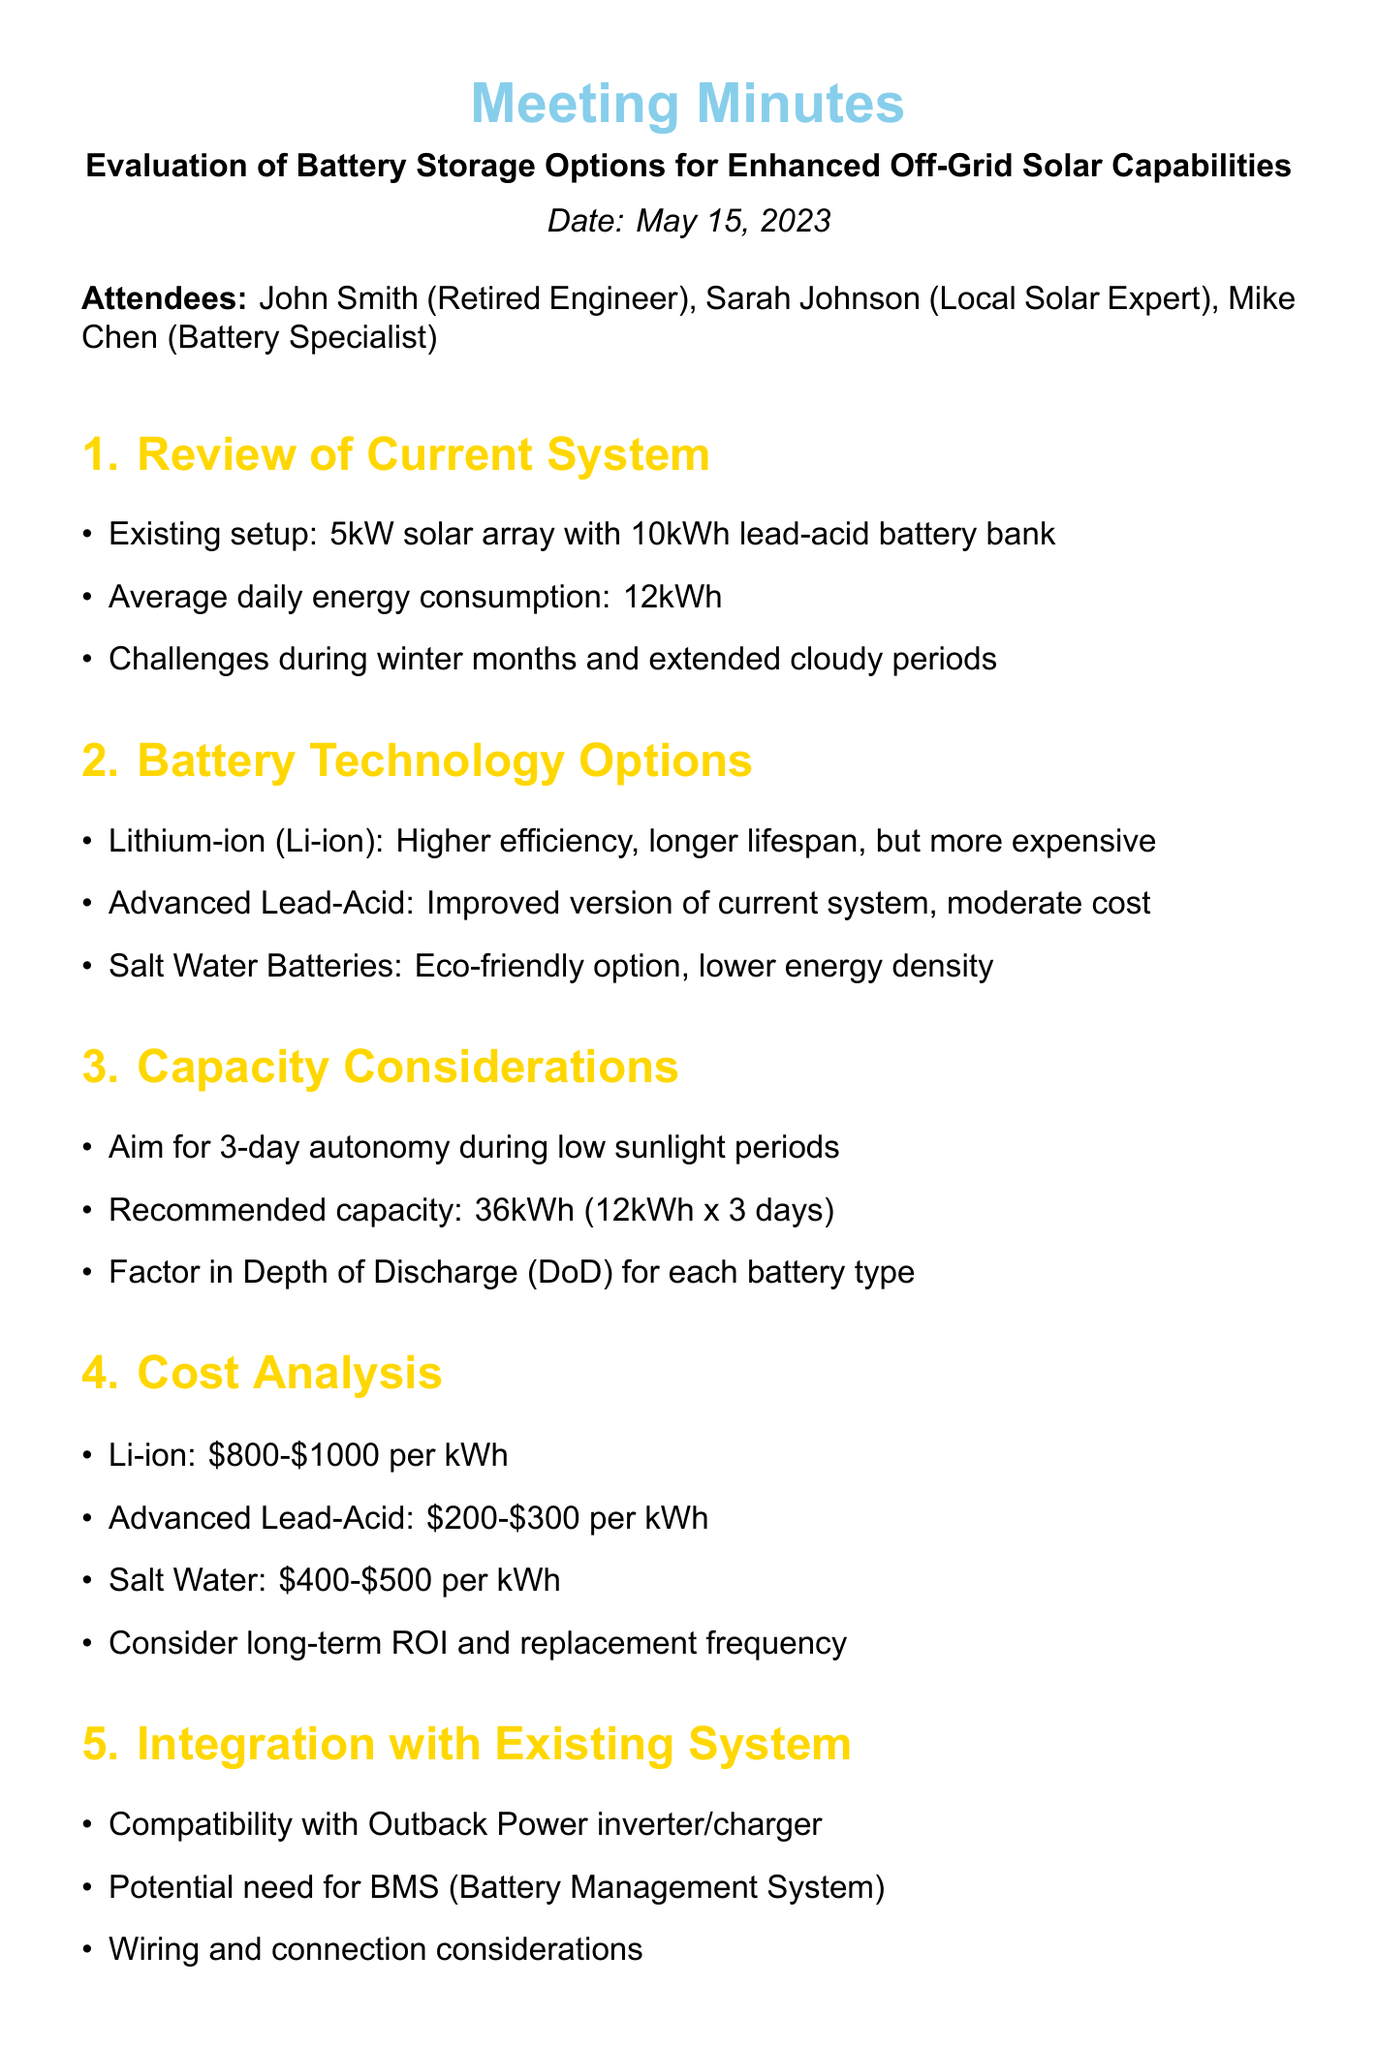What is the date of the meeting? The date of the meeting is specified in the document.
Answer: May 15, 2023 Who is the battery specialist in the meeting? The attendees list includes the roles and names of participants.
Answer: Mike Chen What is the recommended battery capacity for 3-day autonomy? The capacity considerations section provides the recommended capacity.
Answer: 36kWh What is the cost range for lithium-ion batteries per kWh? The cost analysis section outlines the costs for different battery technologies.
Answer: $800-$1000 What challenges does the current system face? The review of the current system mentions specific challenges encountered.
Answer: Winter months and extended cloudy periods What is an example of an eco-friendly battery option discussed? The battery technology options section lists various battery types, including eco-friendly options.
Answer: Salt Water Batteries What is the average daily energy consumption? The review of the current system states the average daily energy consumption.
Answer: 12kWh What is one of the next steps mentioned? The next steps section outlines actions to be taken following the meeting.
Answer: Research local suppliers for chosen battery technology 